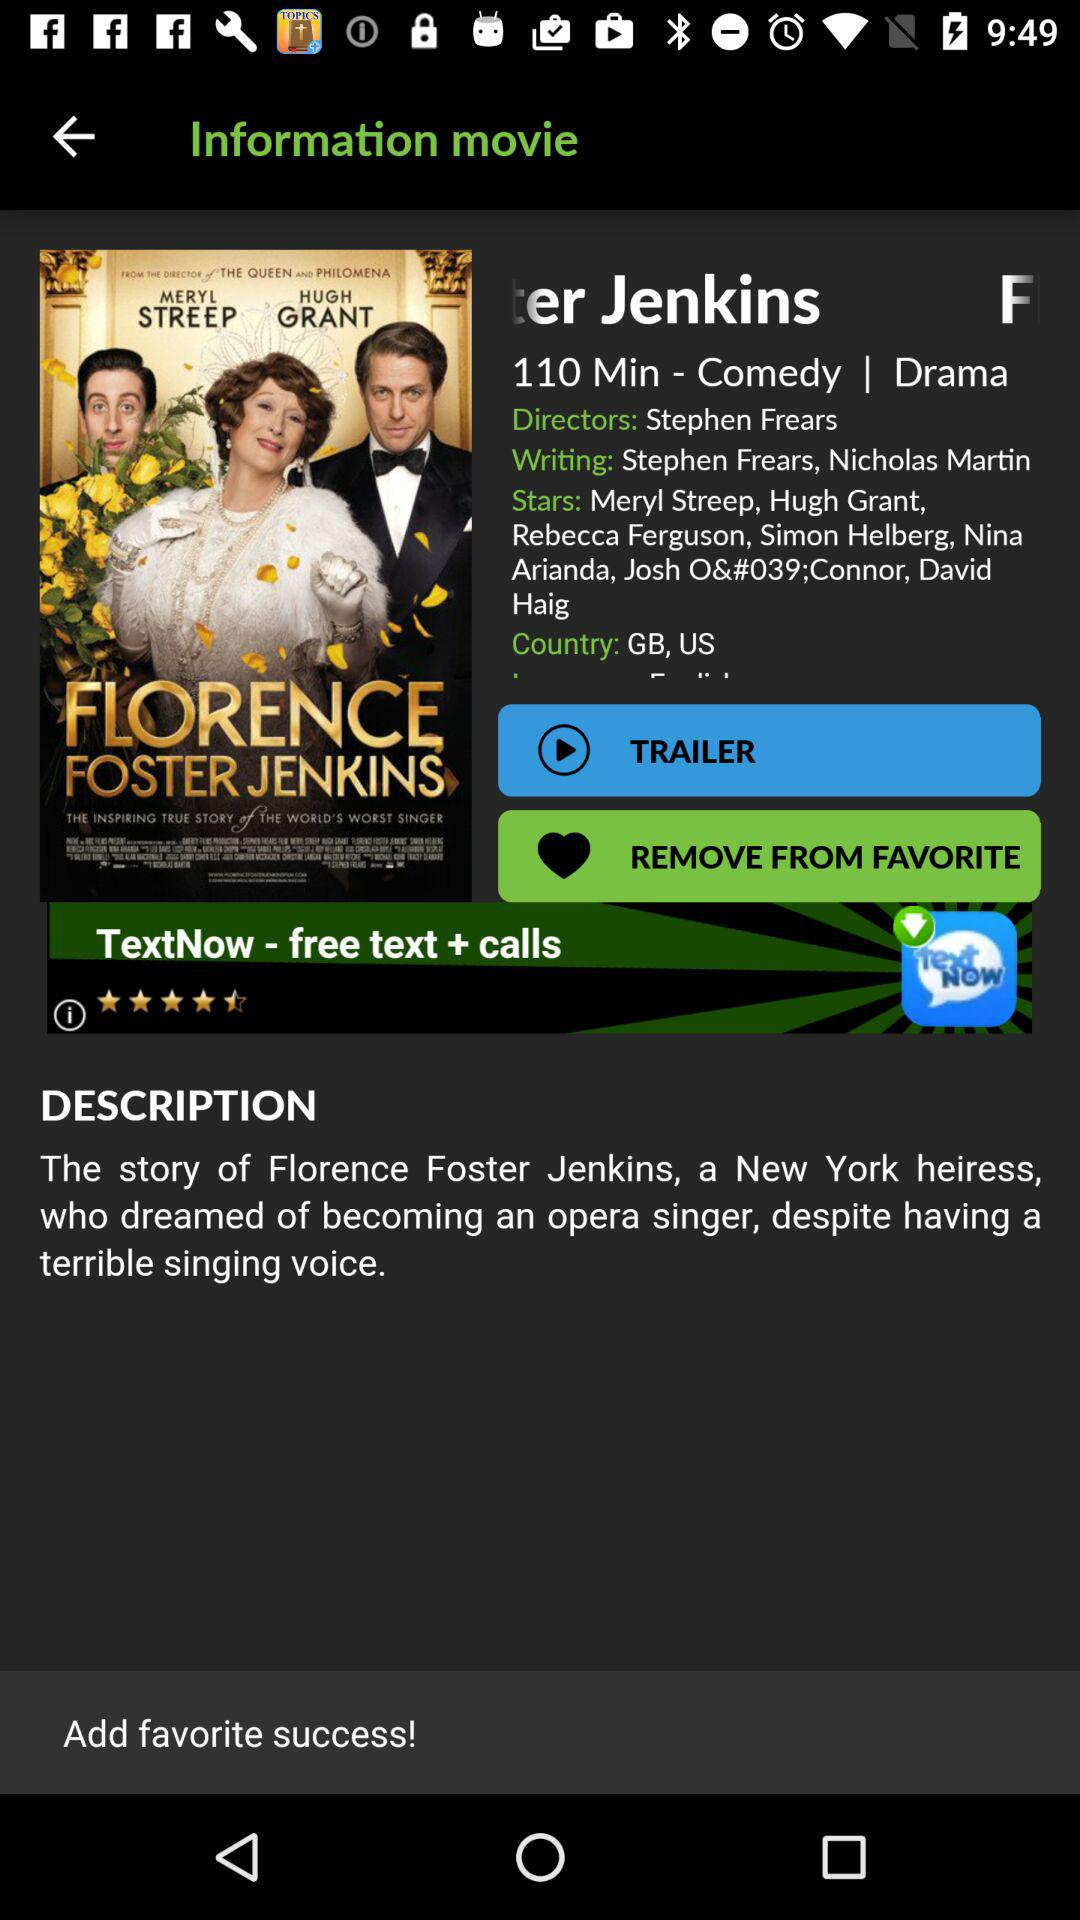Who is the director of the movie? The director of the movie is Stephen Frears. 